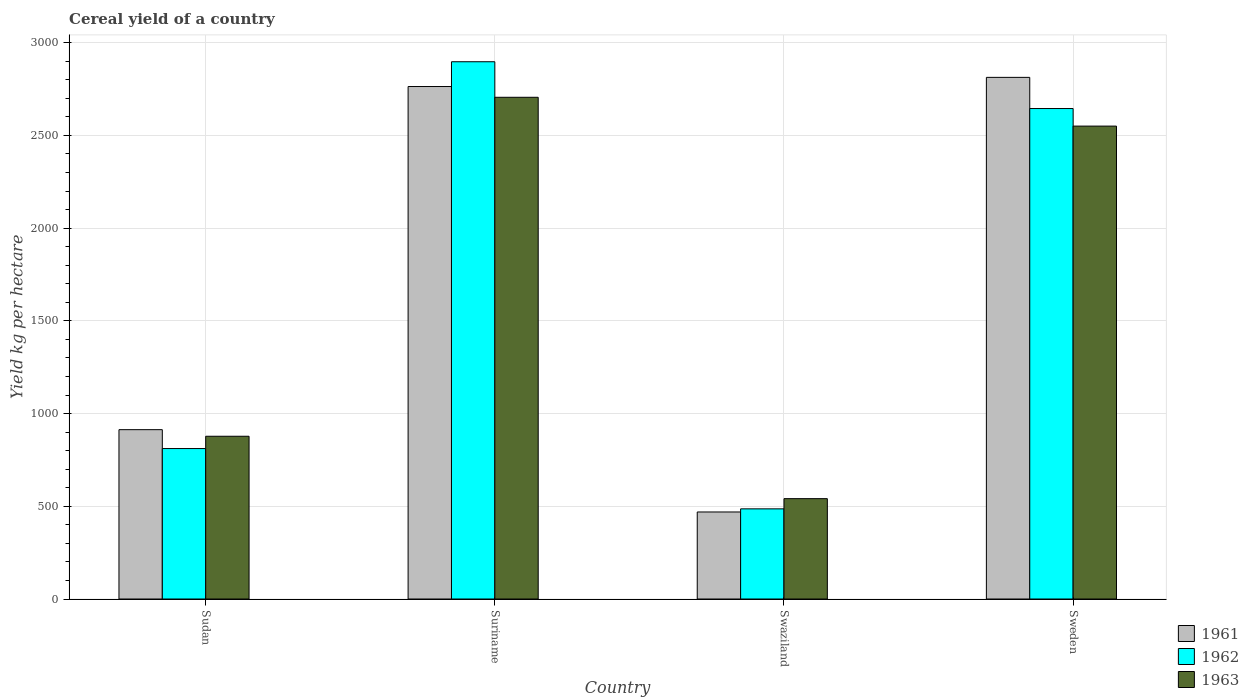How many different coloured bars are there?
Provide a succinct answer. 3. What is the label of the 4th group of bars from the left?
Your answer should be very brief. Sweden. What is the total cereal yield in 1962 in Swaziland?
Your response must be concise. 486.15. Across all countries, what is the maximum total cereal yield in 1961?
Keep it short and to the point. 2812.7. Across all countries, what is the minimum total cereal yield in 1962?
Make the answer very short. 486.15. In which country was the total cereal yield in 1963 maximum?
Keep it short and to the point. Suriname. In which country was the total cereal yield in 1962 minimum?
Your answer should be very brief. Swaziland. What is the total total cereal yield in 1961 in the graph?
Ensure brevity in your answer.  6958.41. What is the difference between the total cereal yield in 1961 in Suriname and that in Sweden?
Provide a succinct answer. -49.33. What is the difference between the total cereal yield in 1963 in Suriname and the total cereal yield in 1962 in Sweden?
Keep it short and to the point. 60.63. What is the average total cereal yield in 1963 per country?
Make the answer very short. 1668.49. What is the difference between the total cereal yield of/in 1961 and total cereal yield of/in 1962 in Swaziland?
Your response must be concise. -16.9. In how many countries, is the total cereal yield in 1963 greater than 1300 kg per hectare?
Offer a very short reply. 2. What is the ratio of the total cereal yield in 1962 in Suriname to that in Sweden?
Make the answer very short. 1.1. What is the difference between the highest and the second highest total cereal yield in 1963?
Make the answer very short. 1827.75. What is the difference between the highest and the lowest total cereal yield in 1963?
Your response must be concise. 2164.2. In how many countries, is the total cereal yield in 1963 greater than the average total cereal yield in 1963 taken over all countries?
Offer a very short reply. 2. Is the sum of the total cereal yield in 1962 in Suriname and Sweden greater than the maximum total cereal yield in 1963 across all countries?
Offer a very short reply. Yes. What does the 1st bar from the left in Sudan represents?
Offer a very short reply. 1961. What does the 2nd bar from the right in Suriname represents?
Keep it short and to the point. 1962. Is it the case that in every country, the sum of the total cereal yield in 1962 and total cereal yield in 1961 is greater than the total cereal yield in 1963?
Offer a very short reply. Yes. How many bars are there?
Ensure brevity in your answer.  12. Are all the bars in the graph horizontal?
Offer a very short reply. No. What is the difference between two consecutive major ticks on the Y-axis?
Your answer should be compact. 500. Does the graph contain grids?
Make the answer very short. Yes. What is the title of the graph?
Keep it short and to the point. Cereal yield of a country. Does "2010" appear as one of the legend labels in the graph?
Keep it short and to the point. No. What is the label or title of the X-axis?
Offer a very short reply. Country. What is the label or title of the Y-axis?
Offer a terse response. Yield kg per hectare. What is the Yield kg per hectare of 1961 in Sudan?
Your answer should be very brief. 913.1. What is the Yield kg per hectare in 1962 in Sudan?
Your answer should be compact. 811.23. What is the Yield kg per hectare in 1963 in Sudan?
Provide a succinct answer. 877.56. What is the Yield kg per hectare in 1961 in Suriname?
Provide a succinct answer. 2763.36. What is the Yield kg per hectare in 1962 in Suriname?
Offer a very short reply. 2897.01. What is the Yield kg per hectare of 1963 in Suriname?
Your answer should be very brief. 2705.31. What is the Yield kg per hectare of 1961 in Swaziland?
Your answer should be compact. 469.25. What is the Yield kg per hectare of 1962 in Swaziland?
Offer a terse response. 486.15. What is the Yield kg per hectare of 1963 in Swaziland?
Provide a succinct answer. 541.11. What is the Yield kg per hectare in 1961 in Sweden?
Give a very brief answer. 2812.7. What is the Yield kg per hectare in 1962 in Sweden?
Your answer should be compact. 2644.68. What is the Yield kg per hectare of 1963 in Sweden?
Your answer should be very brief. 2549.97. Across all countries, what is the maximum Yield kg per hectare in 1961?
Give a very brief answer. 2812.7. Across all countries, what is the maximum Yield kg per hectare of 1962?
Your answer should be compact. 2897.01. Across all countries, what is the maximum Yield kg per hectare in 1963?
Keep it short and to the point. 2705.31. Across all countries, what is the minimum Yield kg per hectare of 1961?
Ensure brevity in your answer.  469.25. Across all countries, what is the minimum Yield kg per hectare in 1962?
Your answer should be compact. 486.15. Across all countries, what is the minimum Yield kg per hectare of 1963?
Offer a terse response. 541.11. What is the total Yield kg per hectare in 1961 in the graph?
Give a very brief answer. 6958.41. What is the total Yield kg per hectare in 1962 in the graph?
Make the answer very short. 6839.06. What is the total Yield kg per hectare of 1963 in the graph?
Offer a terse response. 6673.95. What is the difference between the Yield kg per hectare of 1961 in Sudan and that in Suriname?
Your response must be concise. -1850.27. What is the difference between the Yield kg per hectare in 1962 in Sudan and that in Suriname?
Keep it short and to the point. -2085.78. What is the difference between the Yield kg per hectare in 1963 in Sudan and that in Suriname?
Your response must be concise. -1827.75. What is the difference between the Yield kg per hectare of 1961 in Sudan and that in Swaziland?
Offer a terse response. 443.84. What is the difference between the Yield kg per hectare of 1962 in Sudan and that in Swaziland?
Keep it short and to the point. 325.08. What is the difference between the Yield kg per hectare of 1963 in Sudan and that in Swaziland?
Your answer should be compact. 336.45. What is the difference between the Yield kg per hectare in 1961 in Sudan and that in Sweden?
Provide a succinct answer. -1899.6. What is the difference between the Yield kg per hectare of 1962 in Sudan and that in Sweden?
Offer a terse response. -1833.45. What is the difference between the Yield kg per hectare of 1963 in Sudan and that in Sweden?
Give a very brief answer. -1672.41. What is the difference between the Yield kg per hectare of 1961 in Suriname and that in Swaziland?
Give a very brief answer. 2294.11. What is the difference between the Yield kg per hectare in 1962 in Suriname and that in Swaziland?
Provide a short and direct response. 2410.86. What is the difference between the Yield kg per hectare in 1963 in Suriname and that in Swaziland?
Provide a short and direct response. 2164.2. What is the difference between the Yield kg per hectare in 1961 in Suriname and that in Sweden?
Offer a terse response. -49.33. What is the difference between the Yield kg per hectare of 1962 in Suriname and that in Sweden?
Keep it short and to the point. 252.33. What is the difference between the Yield kg per hectare in 1963 in Suriname and that in Sweden?
Offer a terse response. 155.34. What is the difference between the Yield kg per hectare of 1961 in Swaziland and that in Sweden?
Your answer should be very brief. -2343.44. What is the difference between the Yield kg per hectare of 1962 in Swaziland and that in Sweden?
Your answer should be compact. -2158.53. What is the difference between the Yield kg per hectare in 1963 in Swaziland and that in Sweden?
Provide a short and direct response. -2008.86. What is the difference between the Yield kg per hectare of 1961 in Sudan and the Yield kg per hectare of 1962 in Suriname?
Ensure brevity in your answer.  -1983.91. What is the difference between the Yield kg per hectare of 1961 in Sudan and the Yield kg per hectare of 1963 in Suriname?
Keep it short and to the point. -1792.21. What is the difference between the Yield kg per hectare in 1962 in Sudan and the Yield kg per hectare in 1963 in Suriname?
Your answer should be compact. -1894.09. What is the difference between the Yield kg per hectare of 1961 in Sudan and the Yield kg per hectare of 1962 in Swaziland?
Your answer should be compact. 426.95. What is the difference between the Yield kg per hectare of 1961 in Sudan and the Yield kg per hectare of 1963 in Swaziland?
Keep it short and to the point. 371.98. What is the difference between the Yield kg per hectare of 1962 in Sudan and the Yield kg per hectare of 1963 in Swaziland?
Ensure brevity in your answer.  270.11. What is the difference between the Yield kg per hectare of 1961 in Sudan and the Yield kg per hectare of 1962 in Sweden?
Your answer should be very brief. -1731.58. What is the difference between the Yield kg per hectare in 1961 in Sudan and the Yield kg per hectare in 1963 in Sweden?
Offer a very short reply. -1636.88. What is the difference between the Yield kg per hectare of 1962 in Sudan and the Yield kg per hectare of 1963 in Sweden?
Ensure brevity in your answer.  -1738.75. What is the difference between the Yield kg per hectare of 1961 in Suriname and the Yield kg per hectare of 1962 in Swaziland?
Your response must be concise. 2277.22. What is the difference between the Yield kg per hectare of 1961 in Suriname and the Yield kg per hectare of 1963 in Swaziland?
Provide a short and direct response. 2222.25. What is the difference between the Yield kg per hectare of 1962 in Suriname and the Yield kg per hectare of 1963 in Swaziland?
Your response must be concise. 2355.89. What is the difference between the Yield kg per hectare of 1961 in Suriname and the Yield kg per hectare of 1962 in Sweden?
Your response must be concise. 118.69. What is the difference between the Yield kg per hectare in 1961 in Suriname and the Yield kg per hectare in 1963 in Sweden?
Ensure brevity in your answer.  213.39. What is the difference between the Yield kg per hectare in 1962 in Suriname and the Yield kg per hectare in 1963 in Sweden?
Your answer should be very brief. 347.04. What is the difference between the Yield kg per hectare of 1961 in Swaziland and the Yield kg per hectare of 1962 in Sweden?
Give a very brief answer. -2175.43. What is the difference between the Yield kg per hectare of 1961 in Swaziland and the Yield kg per hectare of 1963 in Sweden?
Provide a short and direct response. -2080.72. What is the difference between the Yield kg per hectare in 1962 in Swaziland and the Yield kg per hectare in 1963 in Sweden?
Your answer should be very brief. -2063.82. What is the average Yield kg per hectare of 1961 per country?
Offer a very short reply. 1739.6. What is the average Yield kg per hectare of 1962 per country?
Provide a succinct answer. 1709.76. What is the average Yield kg per hectare of 1963 per country?
Provide a short and direct response. 1668.49. What is the difference between the Yield kg per hectare in 1961 and Yield kg per hectare in 1962 in Sudan?
Ensure brevity in your answer.  101.87. What is the difference between the Yield kg per hectare in 1961 and Yield kg per hectare in 1963 in Sudan?
Your response must be concise. 35.53. What is the difference between the Yield kg per hectare of 1962 and Yield kg per hectare of 1963 in Sudan?
Offer a terse response. -66.34. What is the difference between the Yield kg per hectare of 1961 and Yield kg per hectare of 1962 in Suriname?
Offer a terse response. -133.64. What is the difference between the Yield kg per hectare of 1961 and Yield kg per hectare of 1963 in Suriname?
Provide a short and direct response. 58.05. What is the difference between the Yield kg per hectare of 1962 and Yield kg per hectare of 1963 in Suriname?
Ensure brevity in your answer.  191.7. What is the difference between the Yield kg per hectare in 1961 and Yield kg per hectare in 1962 in Swaziland?
Your answer should be compact. -16.9. What is the difference between the Yield kg per hectare in 1961 and Yield kg per hectare in 1963 in Swaziland?
Offer a terse response. -71.86. What is the difference between the Yield kg per hectare of 1962 and Yield kg per hectare of 1963 in Swaziland?
Make the answer very short. -54.97. What is the difference between the Yield kg per hectare of 1961 and Yield kg per hectare of 1962 in Sweden?
Provide a short and direct response. 168.02. What is the difference between the Yield kg per hectare of 1961 and Yield kg per hectare of 1963 in Sweden?
Your answer should be very brief. 262.72. What is the difference between the Yield kg per hectare in 1962 and Yield kg per hectare in 1963 in Sweden?
Make the answer very short. 94.71. What is the ratio of the Yield kg per hectare in 1961 in Sudan to that in Suriname?
Keep it short and to the point. 0.33. What is the ratio of the Yield kg per hectare of 1962 in Sudan to that in Suriname?
Your answer should be compact. 0.28. What is the ratio of the Yield kg per hectare in 1963 in Sudan to that in Suriname?
Your answer should be very brief. 0.32. What is the ratio of the Yield kg per hectare of 1961 in Sudan to that in Swaziland?
Make the answer very short. 1.95. What is the ratio of the Yield kg per hectare of 1962 in Sudan to that in Swaziland?
Ensure brevity in your answer.  1.67. What is the ratio of the Yield kg per hectare in 1963 in Sudan to that in Swaziland?
Offer a terse response. 1.62. What is the ratio of the Yield kg per hectare of 1961 in Sudan to that in Sweden?
Your response must be concise. 0.32. What is the ratio of the Yield kg per hectare of 1962 in Sudan to that in Sweden?
Offer a terse response. 0.31. What is the ratio of the Yield kg per hectare of 1963 in Sudan to that in Sweden?
Offer a very short reply. 0.34. What is the ratio of the Yield kg per hectare of 1961 in Suriname to that in Swaziland?
Offer a very short reply. 5.89. What is the ratio of the Yield kg per hectare in 1962 in Suriname to that in Swaziland?
Offer a very short reply. 5.96. What is the ratio of the Yield kg per hectare of 1963 in Suriname to that in Swaziland?
Keep it short and to the point. 5. What is the ratio of the Yield kg per hectare in 1961 in Suriname to that in Sweden?
Your response must be concise. 0.98. What is the ratio of the Yield kg per hectare of 1962 in Suriname to that in Sweden?
Your answer should be very brief. 1.1. What is the ratio of the Yield kg per hectare of 1963 in Suriname to that in Sweden?
Your answer should be compact. 1.06. What is the ratio of the Yield kg per hectare of 1961 in Swaziland to that in Sweden?
Your answer should be compact. 0.17. What is the ratio of the Yield kg per hectare in 1962 in Swaziland to that in Sweden?
Keep it short and to the point. 0.18. What is the ratio of the Yield kg per hectare of 1963 in Swaziland to that in Sweden?
Offer a terse response. 0.21. What is the difference between the highest and the second highest Yield kg per hectare of 1961?
Give a very brief answer. 49.33. What is the difference between the highest and the second highest Yield kg per hectare of 1962?
Your answer should be compact. 252.33. What is the difference between the highest and the second highest Yield kg per hectare of 1963?
Give a very brief answer. 155.34. What is the difference between the highest and the lowest Yield kg per hectare in 1961?
Give a very brief answer. 2343.44. What is the difference between the highest and the lowest Yield kg per hectare in 1962?
Your response must be concise. 2410.86. What is the difference between the highest and the lowest Yield kg per hectare of 1963?
Provide a short and direct response. 2164.2. 